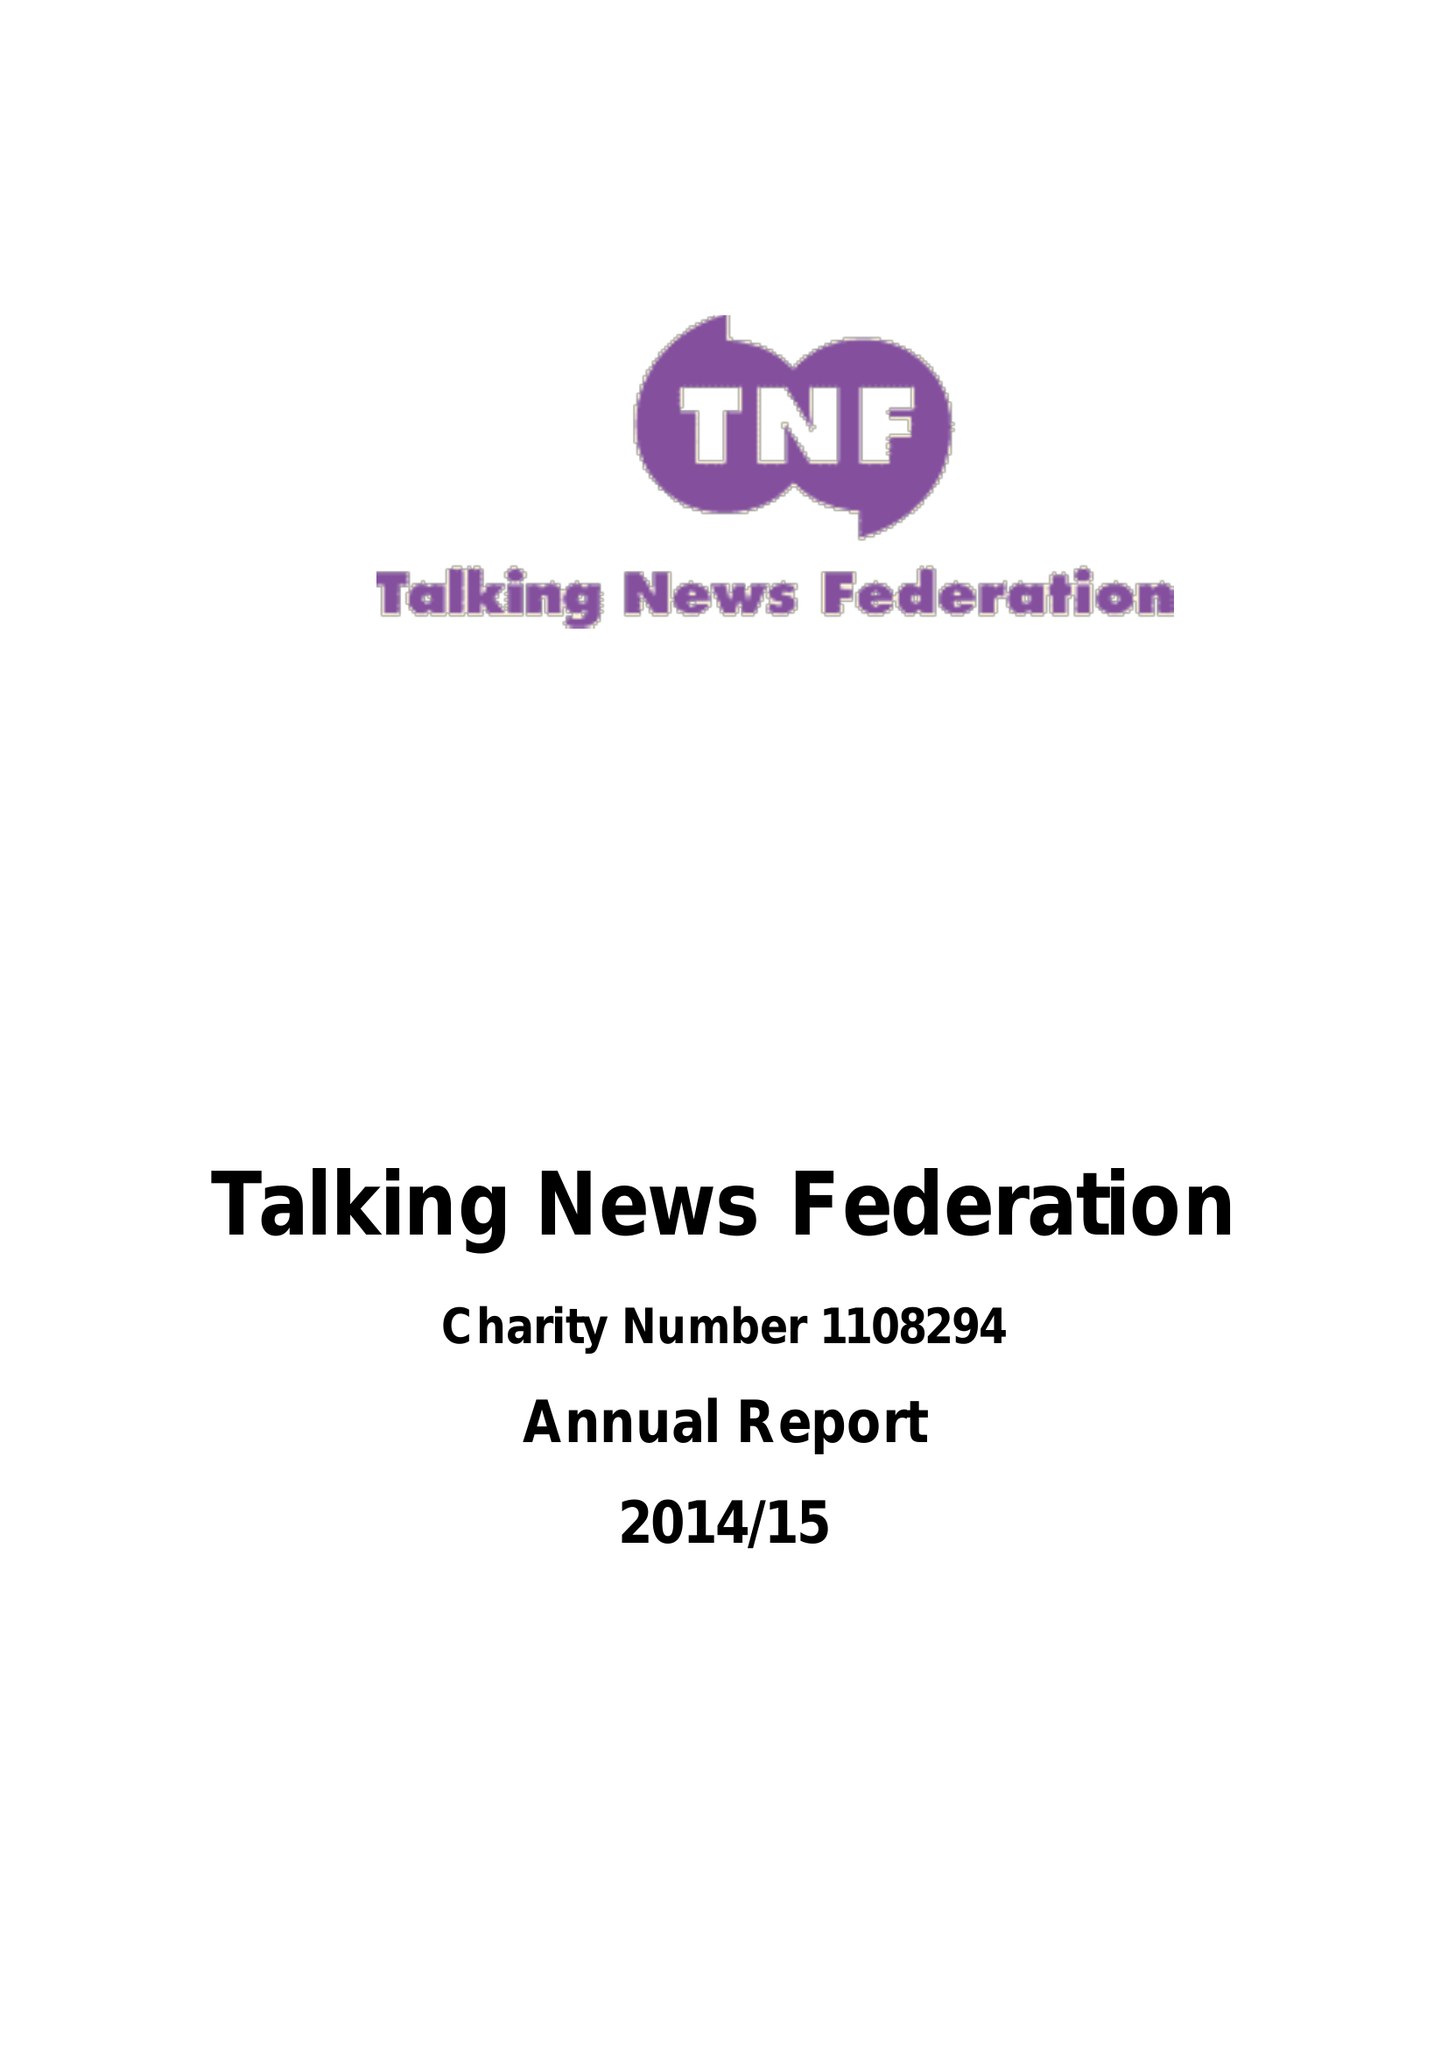What is the value for the address__post_town?
Answer the question using a single word or phrase. SWINDON 